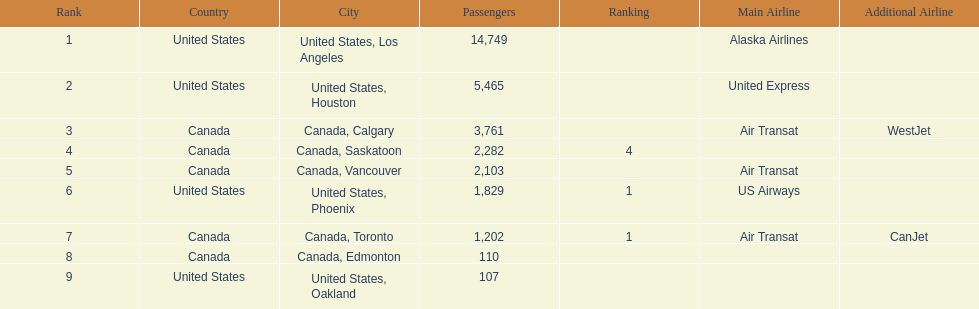Help me parse the entirety of this table. {'header': ['Rank', 'Country', 'City', 'Passengers', 'Ranking', 'Main Airline', 'Additional Airline'], 'rows': [['1', 'United States', 'United States, Los Angeles', '14,749', '', 'Alaska Airlines', ''], ['2', 'United States', 'United States, Houston', '5,465', '', 'United Express', ''], ['3', 'Canada', 'Canada, Calgary', '3,761', '', 'Air Transat', 'WestJet'], ['4', 'Canada', 'Canada, Saskatoon', '2,282', '4', '', ''], ['5', 'Canada', 'Canada, Vancouver', '2,103', '', 'Air Transat', ''], ['6', 'United States', 'United States, Phoenix', '1,829', '1', 'US Airways', ''], ['7', 'Canada', 'Canada, Toronto', '1,202', '1', 'Air Transat', 'CanJet'], ['8', 'Canada', 'Canada, Edmonton', '110', '', '', ''], ['9', 'United States', 'United States, Oakland', '107', '', '', '']]} The least number of passengers came from which city United States, Oakland. 